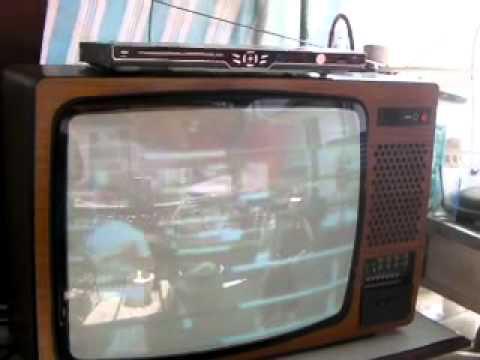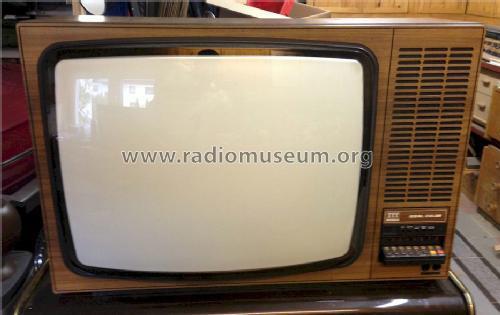The first image is the image on the left, the second image is the image on the right. For the images shown, is this caption "An image shows a TV screen displaying a pattern of squares with a circle in the center." true? Answer yes or no. No. The first image is the image on the left, the second image is the image on the right. Evaluate the accuracy of this statement regarding the images: "One television set is a table top model, while the other is standing on legs, but both have a control and speaker area to the side of the picture tube.". Is it true? Answer yes or no. No. 